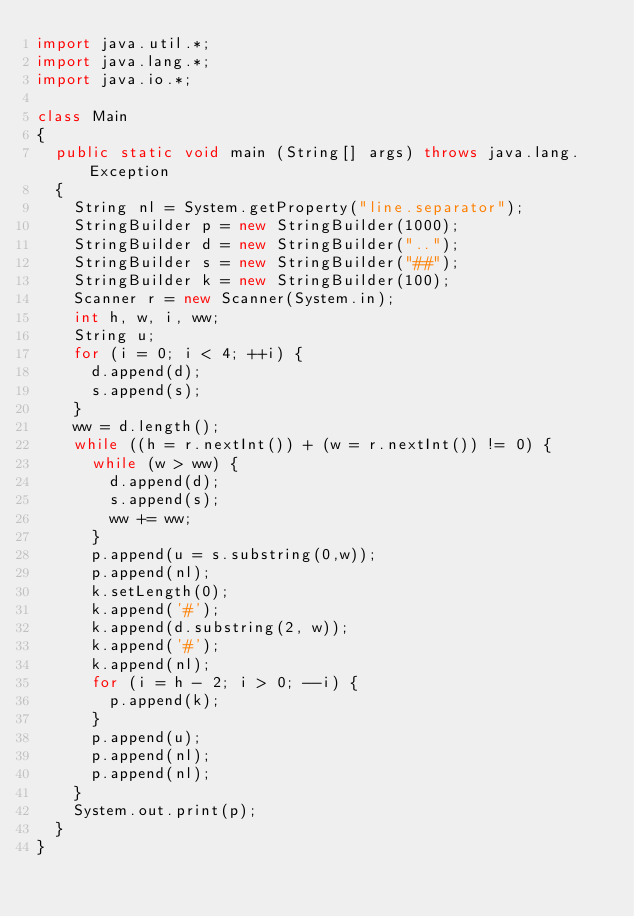Convert code to text. <code><loc_0><loc_0><loc_500><loc_500><_Java_>import java.util.*;
import java.lang.*;
import java.io.*;

class Main
{
	public static void main (String[] args) throws java.lang.Exception
	{
		String nl = System.getProperty("line.separator");
		StringBuilder p = new StringBuilder(1000);
		StringBuilder d = new StringBuilder("..");
		StringBuilder s = new StringBuilder("##");
		StringBuilder k = new StringBuilder(100);
		Scanner r = new Scanner(System.in);
		int h, w, i, ww;
		String u;
		for (i = 0; i < 4; ++i) {
			d.append(d);
			s.append(s);
		}
		ww = d.length();
		while ((h = r.nextInt()) + (w = r.nextInt()) != 0) {
			while (w > ww) {
				d.append(d);
				s.append(s);
				ww += ww;
			}
			p.append(u = s.substring(0,w));
			p.append(nl);
			k.setLength(0);
			k.append('#');
			k.append(d.substring(2, w));
			k.append('#');
			k.append(nl);
			for (i = h - 2; i > 0; --i) {
				p.append(k);
			}
			p.append(u);
			p.append(nl);
			p.append(nl);
		}
		System.out.print(p);
	}
}</code> 